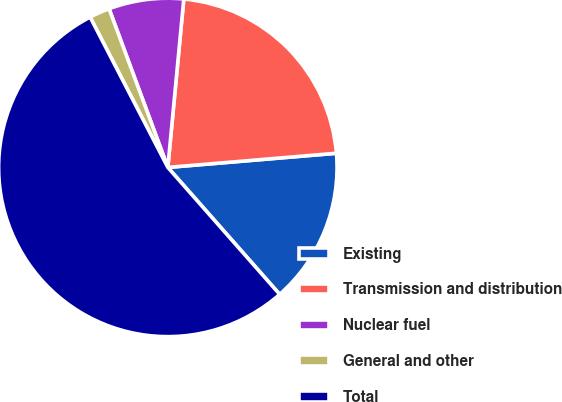<chart> <loc_0><loc_0><loc_500><loc_500><pie_chart><fcel>Existing<fcel>Transmission and distribution<fcel>Nuclear fuel<fcel>General and other<fcel>Total<nl><fcel>14.84%<fcel>22.16%<fcel>7.15%<fcel>1.95%<fcel>53.9%<nl></chart> 